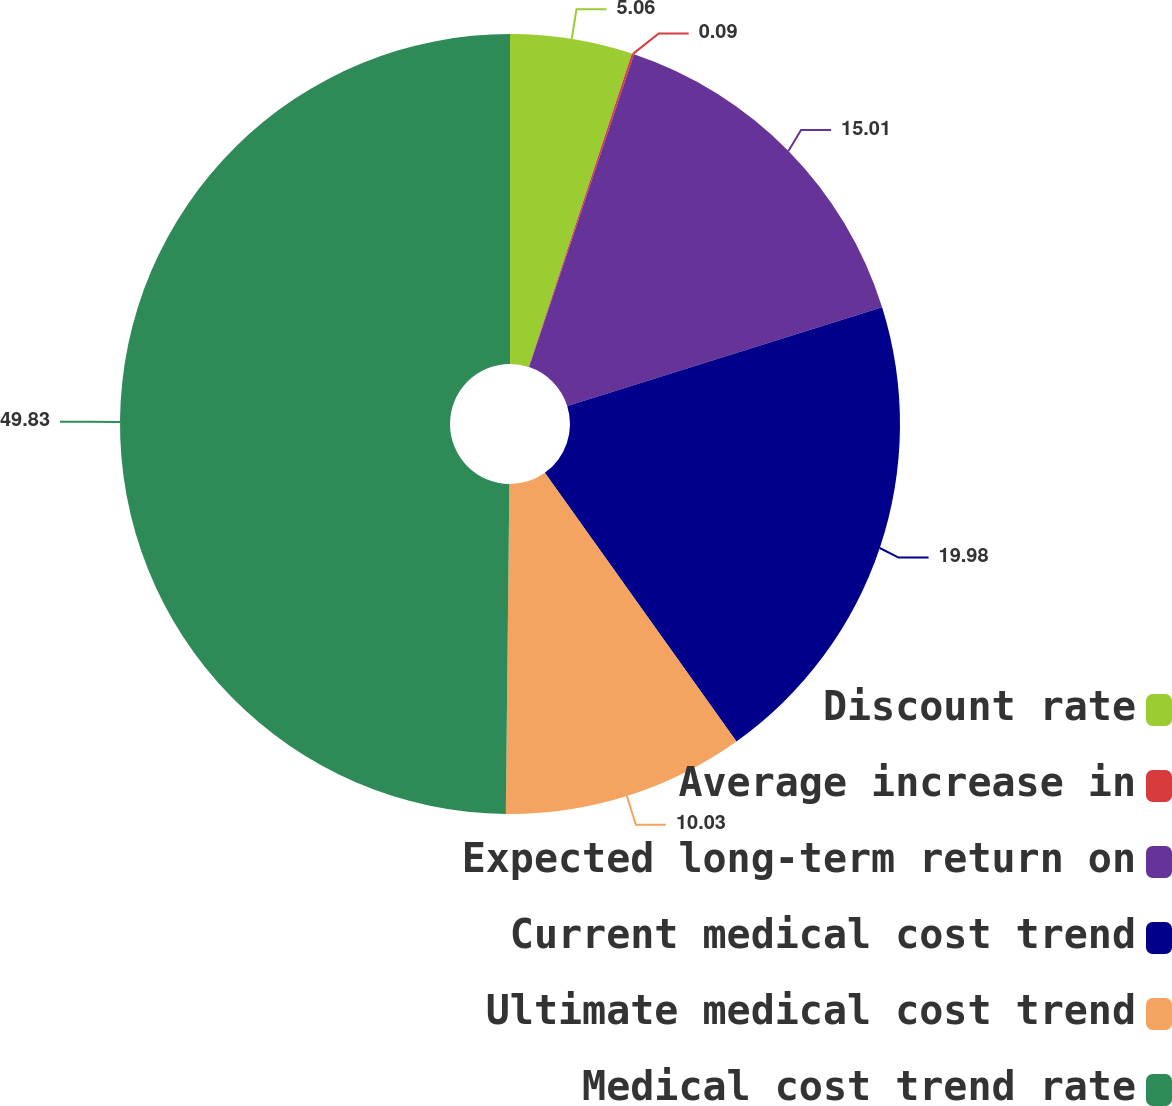<chart> <loc_0><loc_0><loc_500><loc_500><pie_chart><fcel>Discount rate<fcel>Average increase in<fcel>Expected long-term return on<fcel>Current medical cost trend<fcel>Ultimate medical cost trend<fcel>Medical cost trend rate<nl><fcel>5.06%<fcel>0.09%<fcel>15.01%<fcel>19.98%<fcel>10.03%<fcel>49.83%<nl></chart> 